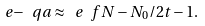<formula> <loc_0><loc_0><loc_500><loc_500>\ e { - \ q a } \approx \ e { \ f { N - N _ { 0 } / 2 } { t } } - 1 .</formula> 